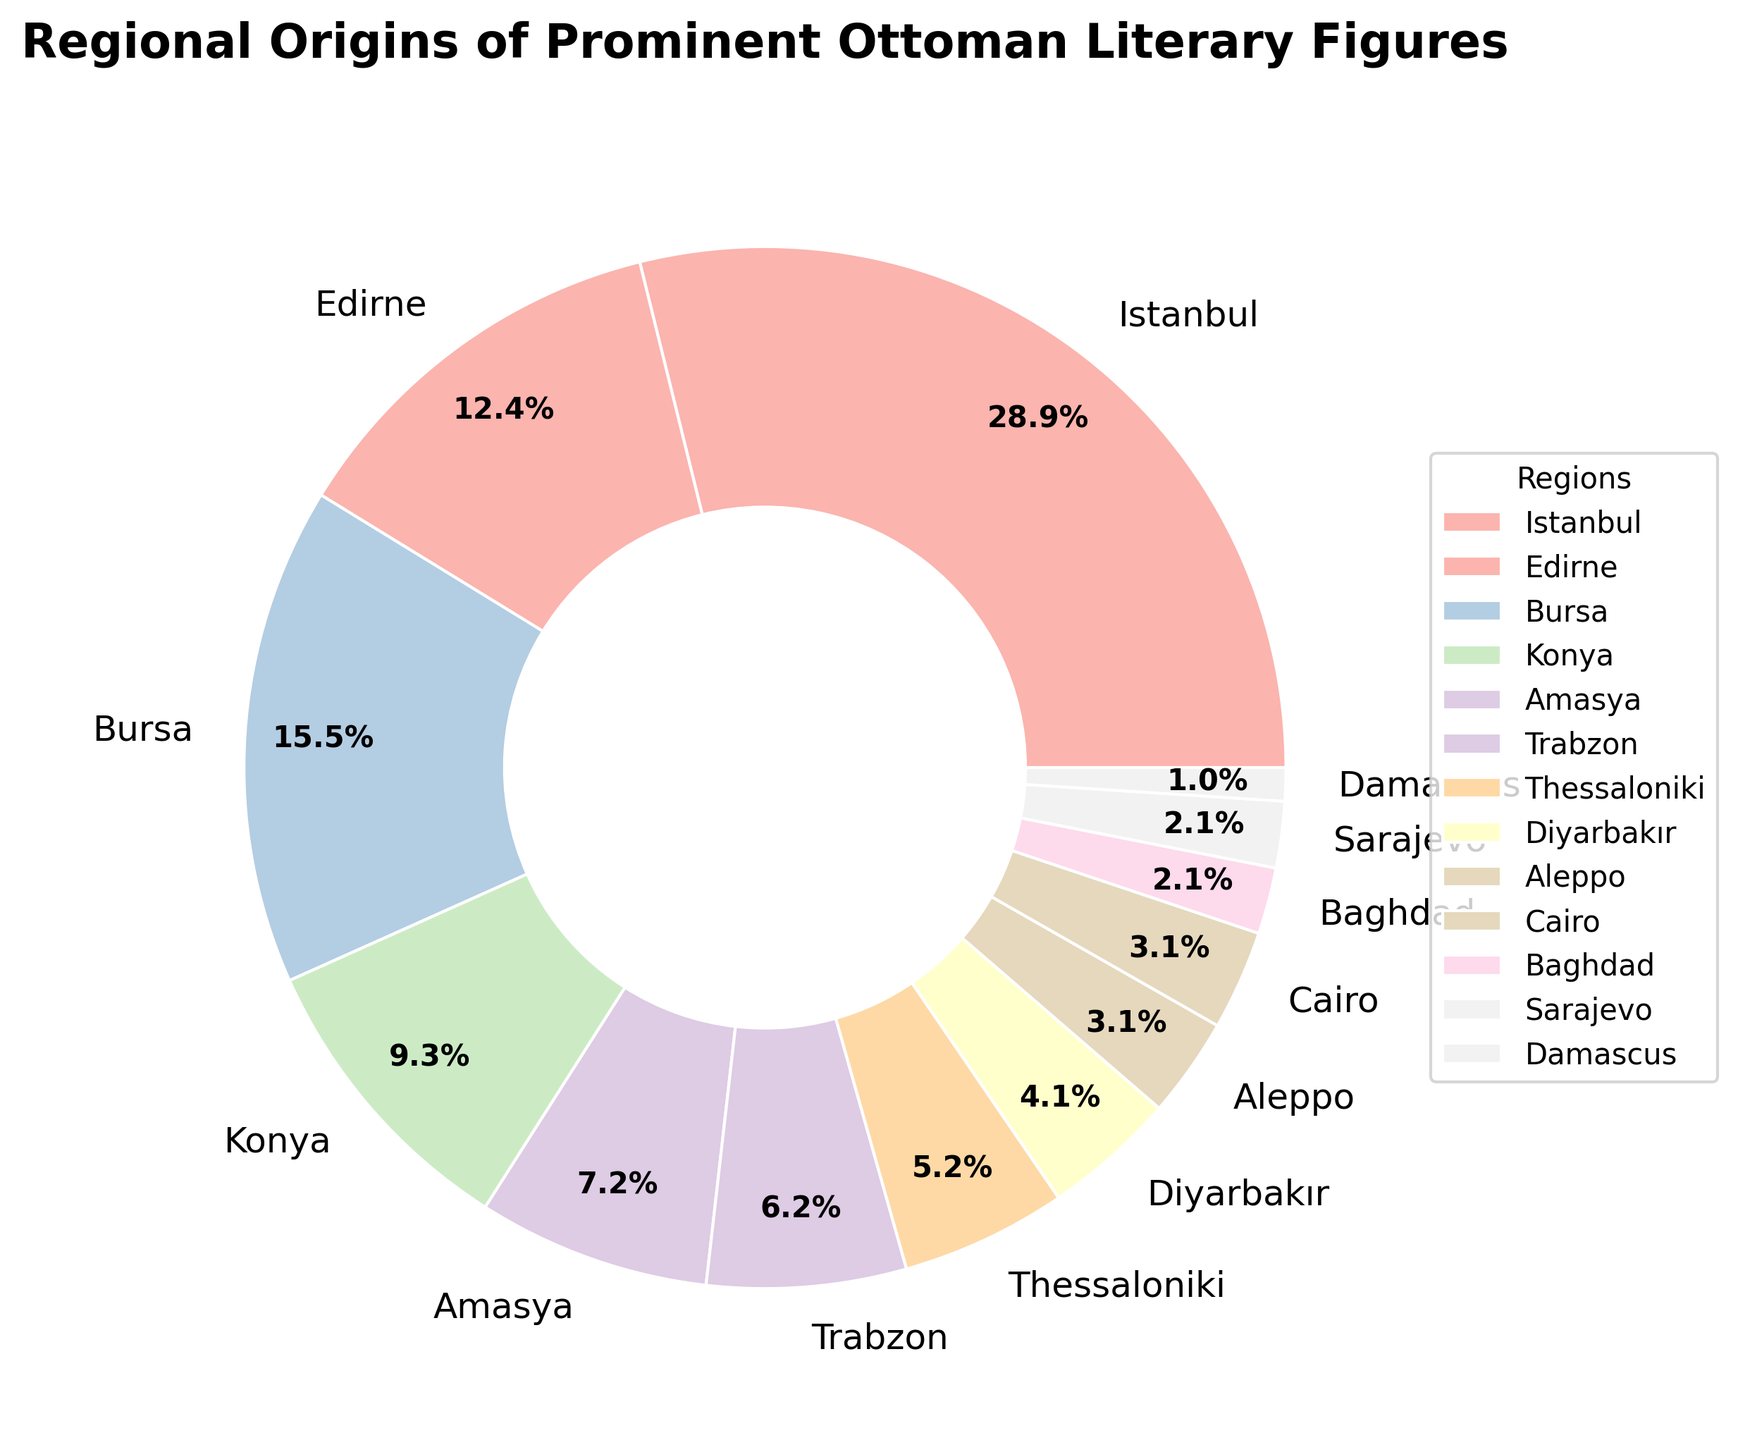Which region has the highest number of prominent Ottoman literary figures? By observing the pie chart, we see that Istanbul has the largest segment, indicating that it has the highest number of prominent Ottoman literary figures.
Answer: Istanbul Which three regions contribute the least number of literary figures? Looking at the smallest slices in the pie chart, we notice that Baghdad, Sarajevo, and Damascus have the smallest segments, indicating they contribute the least number of literary figures.
Answer: Baghdad, Sarajevo, Damascus What is the combined percentage of literary figures from Istanbul and Edirne? Referring to the pie chart, Istanbul has the largest percentage at around 37.8% and Edirne has around 16.2%. Adding these two percentages: 37.8% + 16.2% = 54%.
Answer: 54% How many times more literary figures does Bursa have compared to Diyarbakır? Bursa has 15 literary figures, as indicated by the pie chart, whereas Diyarbakır has 4. Dividing these values, 15 / 4 = 3.75. Therefore, Bursa has 3.75 times more literary figures than Diyarbakır.
Answer: 3.75 times What is the total percentage of literary figures from cities outside of Istanbul, Edirne, and Bursa? The pie chart indicates that Istanbul, Edirne, and Bursa together account for 37.8%, 16.2%, and 20.3% respectively. Adding these, 37.8% + 16.2% + 20.3% = 74.3%. To find the percentage from other cities: 100% - 74.3% = 25.7%.
Answer: 25.7% Which region represents a larger portion of the pie: Konya or Amasya? From the pie chart, we see that the segment for Konya is slightly larger than that for Amasya. This indicates that Konya has more literary figures compared to Amasya.
Answer: Konya What is the difference in the number of literary figures between Trabzon and Thessaloniki? The pie chart data shows Trabzon has 6 literary figures, while Thessaloniki has 5. Subtracting these values gives: 6 - 5 = 1.
Answer: 1 Which region has a similar number of literary figures as Edirne? By looking at the pie chart, we observe that no other region has the same number of literary figures as Edirne (12).
Answer: None What is the proportion of literary figures from Aleppo relative to Cairo? Both Aleppo and Cairo have the same number of literary figures, as seen in the pie chart, each contributing 3 figures. Therefore, the proportion is 1:1.
Answer: 1:1 Based on the pie chart, what can you infer about the geographic distribution of prominent Ottoman literary figures? Istanbul dominates with the largest segment, showing it was a major cultural center. Other regions have smaller contributions, indicating a more dispersed yet significant literary presence in places like Edirne and Bursa, and to a lesser extent in other cities.
Answer: Istanbul is dominant, wide but uneven regional distribution 